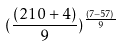<formula> <loc_0><loc_0><loc_500><loc_500>( \frac { ( 2 1 0 + 4 ) } { 9 } ) ^ { \frac { ( 7 - 5 7 ) } { 9 } }</formula> 